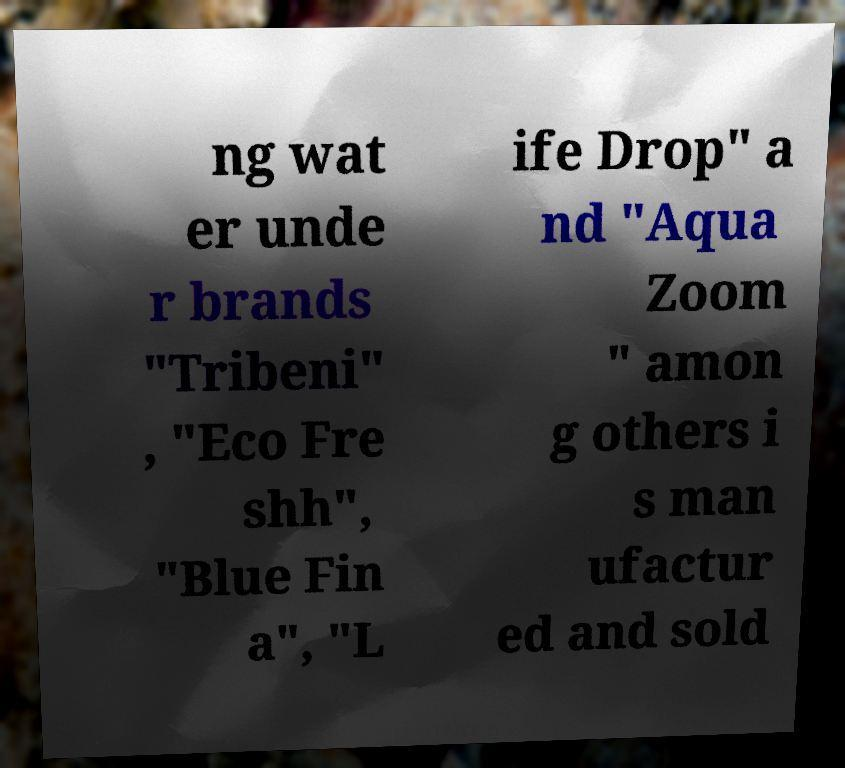I need the written content from this picture converted into text. Can you do that? ng wat er unde r brands "Tribeni" , "Eco Fre shh", "Blue Fin a", "L ife Drop" a nd "Aqua Zoom " amon g others i s man ufactur ed and sold 